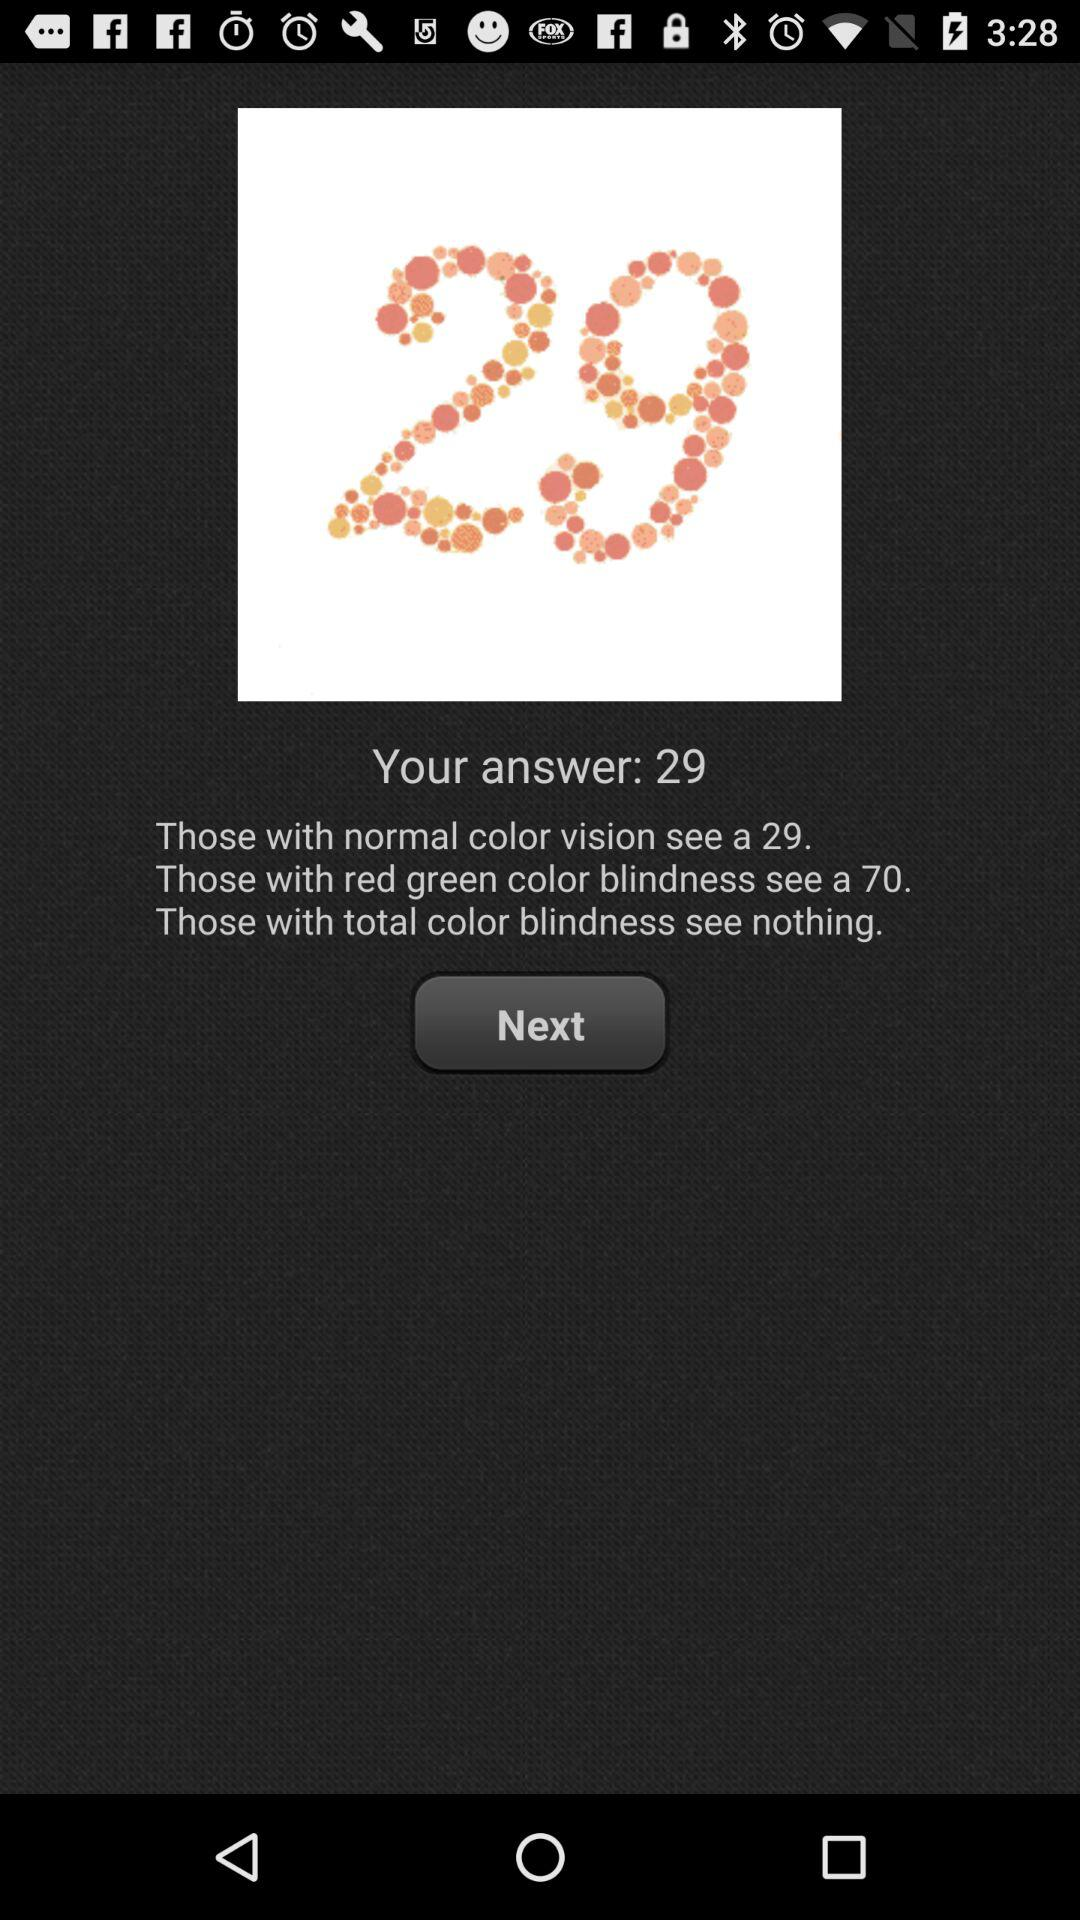What is the answer? The answer is 29. 